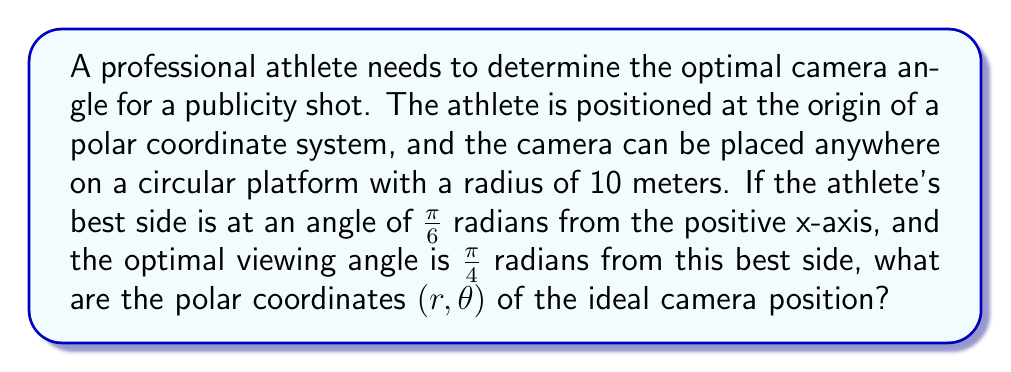Help me with this question. Let's approach this step-by-step:

1) The athlete is at the origin (0, 0) of the polar coordinate system.

2) The athlete's best side is at an angle of $\frac{\pi}{6}$ radians from the positive x-axis.

3) The optimal viewing angle is $\frac{\pi}{4}$ radians from the best side.

4) To find the angle $\theta$ for the camera position, we need to add these angles:

   $\theta = \frac{\pi}{6} + \frac{\pi}{4} = \frac{\pi}{6} + \frac{2\pi}{8} = \frac{4\pi + 3\pi}{12} = \frac{7\pi}{12}$ radians

5) The radius $r$ is given as 10 meters (the radius of the circular platform).

Therefore, the polar coordinates of the ideal camera position are $(10, \frac{7\pi}{12})$.

To visualize:

[asy]
import geometry;

size(200);
draw(circle((0,0),10), blue);
draw((0,0)--(10,0), gray+dashed);
draw((0,0)--(10*cos(7*pi/12),10*sin(7*pi/12)), red);
dot((0,0), blue);
dot((10*cos(7*pi/12),10*sin(7*pi/12)), red);
label("Athlete", (0,0), SW);
label("Camera", (10*cos(7*pi/12),10*sin(7*pi/12)), NE);
draw(arc((0,0),2,0,7*pi/12), arrow=Arrow());
label("$\frac{7\pi}{12}$", (1.5,0.5));
[/asy]
Answer: $(10, \frac{7\pi}{12})$ 